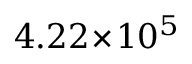Convert formula to latex. <formula><loc_0><loc_0><loc_500><loc_500>4 . 2 2 \, \times \, 1 0 ^ { 5 }</formula> 